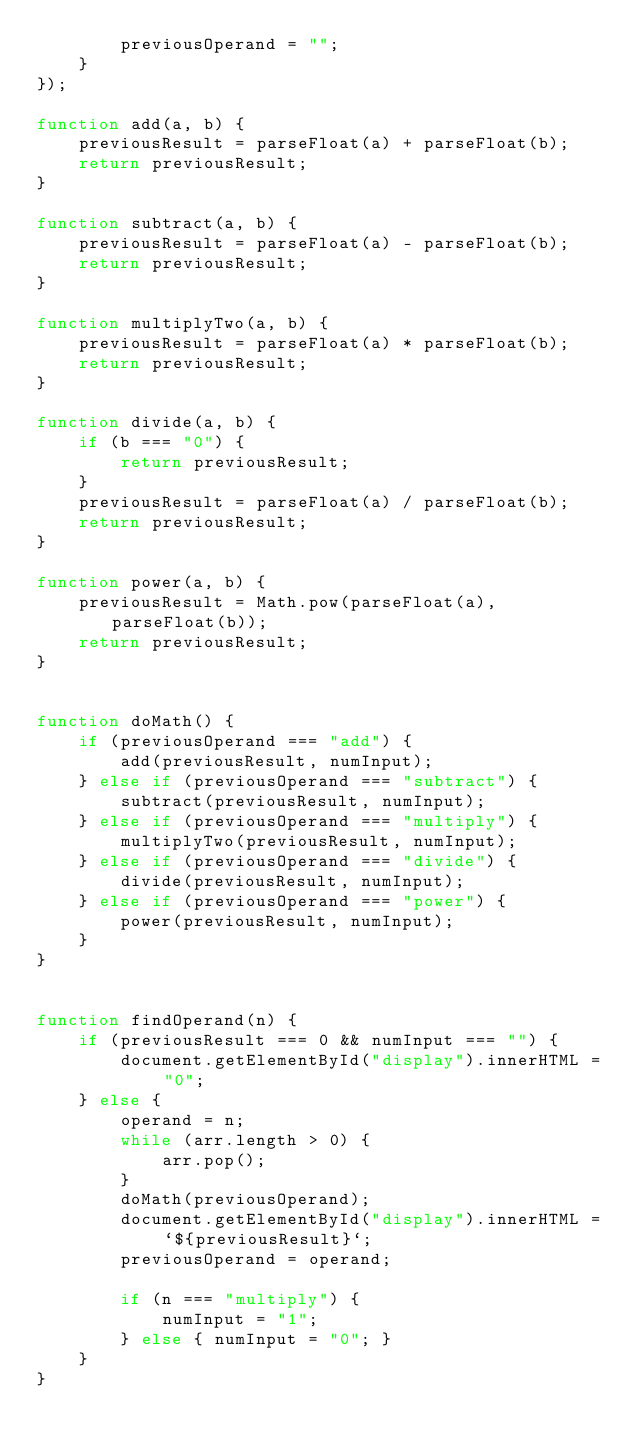Convert code to text. <code><loc_0><loc_0><loc_500><loc_500><_JavaScript_>        previousOperand = "";
    }
});

function add(a, b) {
    previousResult = parseFloat(a) + parseFloat(b);
    return previousResult;
}

function subtract(a, b) {
    previousResult = parseFloat(a) - parseFloat(b);
    return previousResult;
}

function multiplyTwo(a, b) {
    previousResult = parseFloat(a) * parseFloat(b);
    return previousResult;
}

function divide(a, b) {
    if (b === "0") {
        return previousResult;
    }
    previousResult = parseFloat(a) / parseFloat(b);
    return previousResult;
}

function power(a, b) {
    previousResult = Math.pow(parseFloat(a), parseFloat(b));
    return previousResult;
}


function doMath() {
    if (previousOperand === "add") {
        add(previousResult, numInput);
    } else if (previousOperand === "subtract") {
        subtract(previousResult, numInput);
    } else if (previousOperand === "multiply") {
        multiplyTwo(previousResult, numInput);
    } else if (previousOperand === "divide") {
        divide(previousResult, numInput);
    } else if (previousOperand === "power") {
        power(previousResult, numInput);
    }
}


function findOperand(n) {
    if (previousResult === 0 && numInput === "") {
        document.getElementById("display").innerHTML = "0";
    } else {
        operand = n;
        while (arr.length > 0) {
            arr.pop();
        }
        doMath(previousOperand);
        document.getElementById("display").innerHTML = `${previousResult}`;
        previousOperand = operand;

        if (n === "multiply") {
            numInput = "1";
        } else { numInput = "0"; }
    }
}</code> 